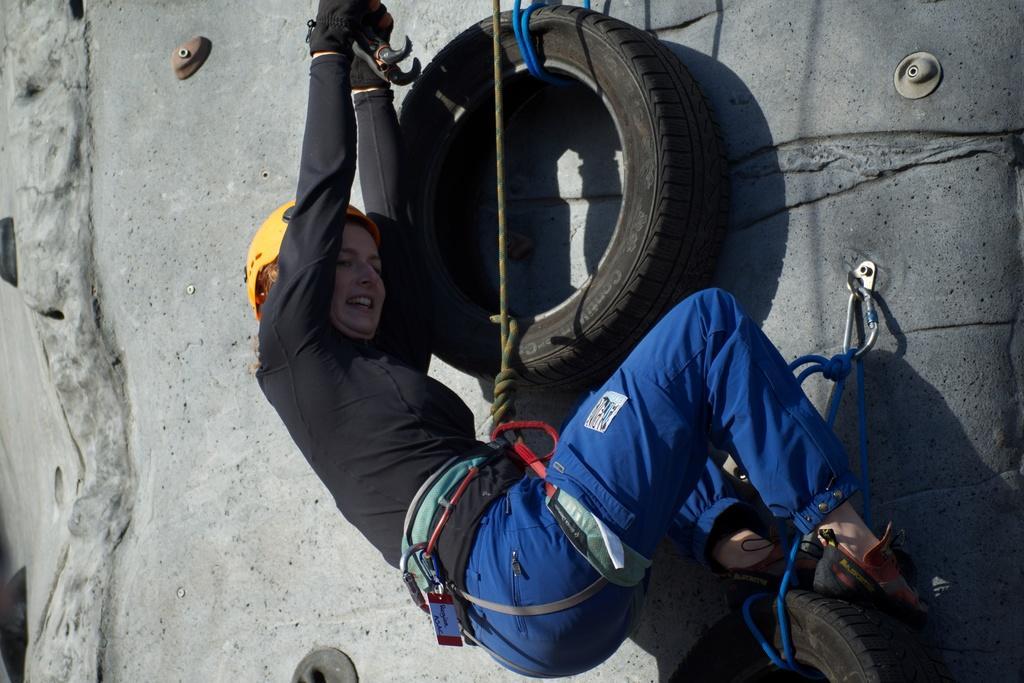Describe this image in one or two sentences. In this image I can see a person wearing black and blue colored dress and yellow color helmet is holding a object and in the background I can see the ash colored surface and a black colored Tyre. 